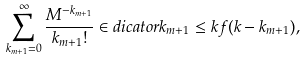Convert formula to latex. <formula><loc_0><loc_0><loc_500><loc_500>\sum _ { k _ { m + 1 } = 0 } ^ { \infty } \frac { M ^ { - k _ { m + 1 } } } { k _ { m + 1 } ! } \in d i c a t o r { k _ { m + 1 } \leq k } f ( k - k _ { m + 1 } ) ,</formula> 